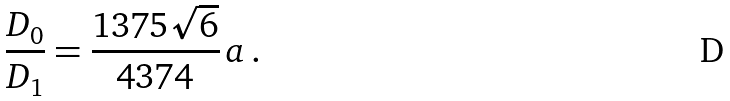Convert formula to latex. <formula><loc_0><loc_0><loc_500><loc_500>\frac { D _ { 0 } } { D _ { 1 } } = \frac { 1 3 7 5 \sqrt { 6 } } { 4 3 7 4 } \, a \, .</formula> 